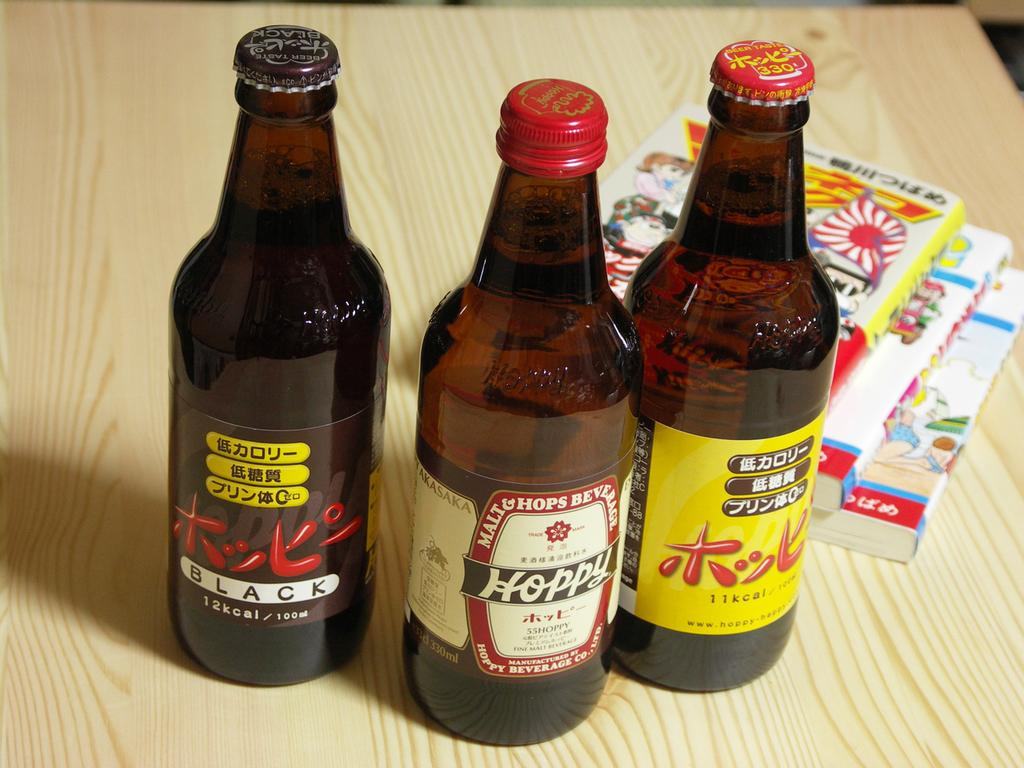Provide a one-sentence caption for the provided image. Three bottles are on a table with the far left one being labeled black. 